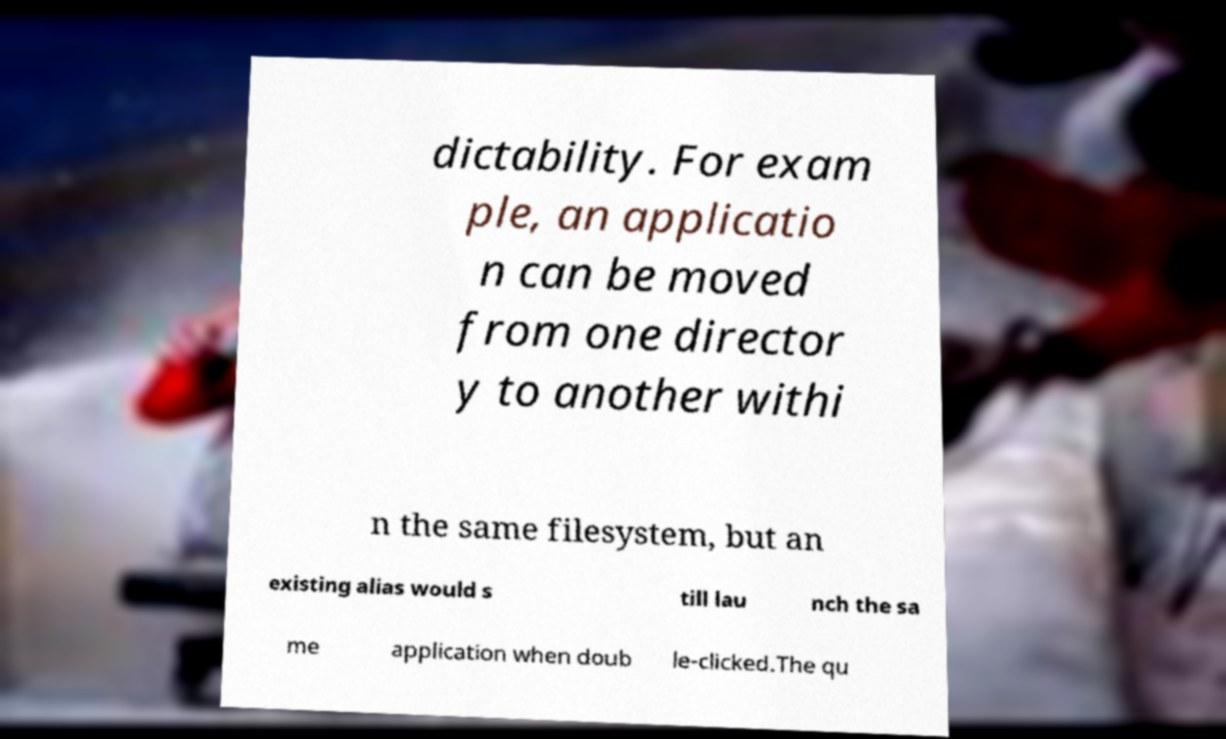Could you assist in decoding the text presented in this image and type it out clearly? dictability. For exam ple, an applicatio n can be moved from one director y to another withi n the same filesystem, but an existing alias would s till lau nch the sa me application when doub le-clicked.The qu 